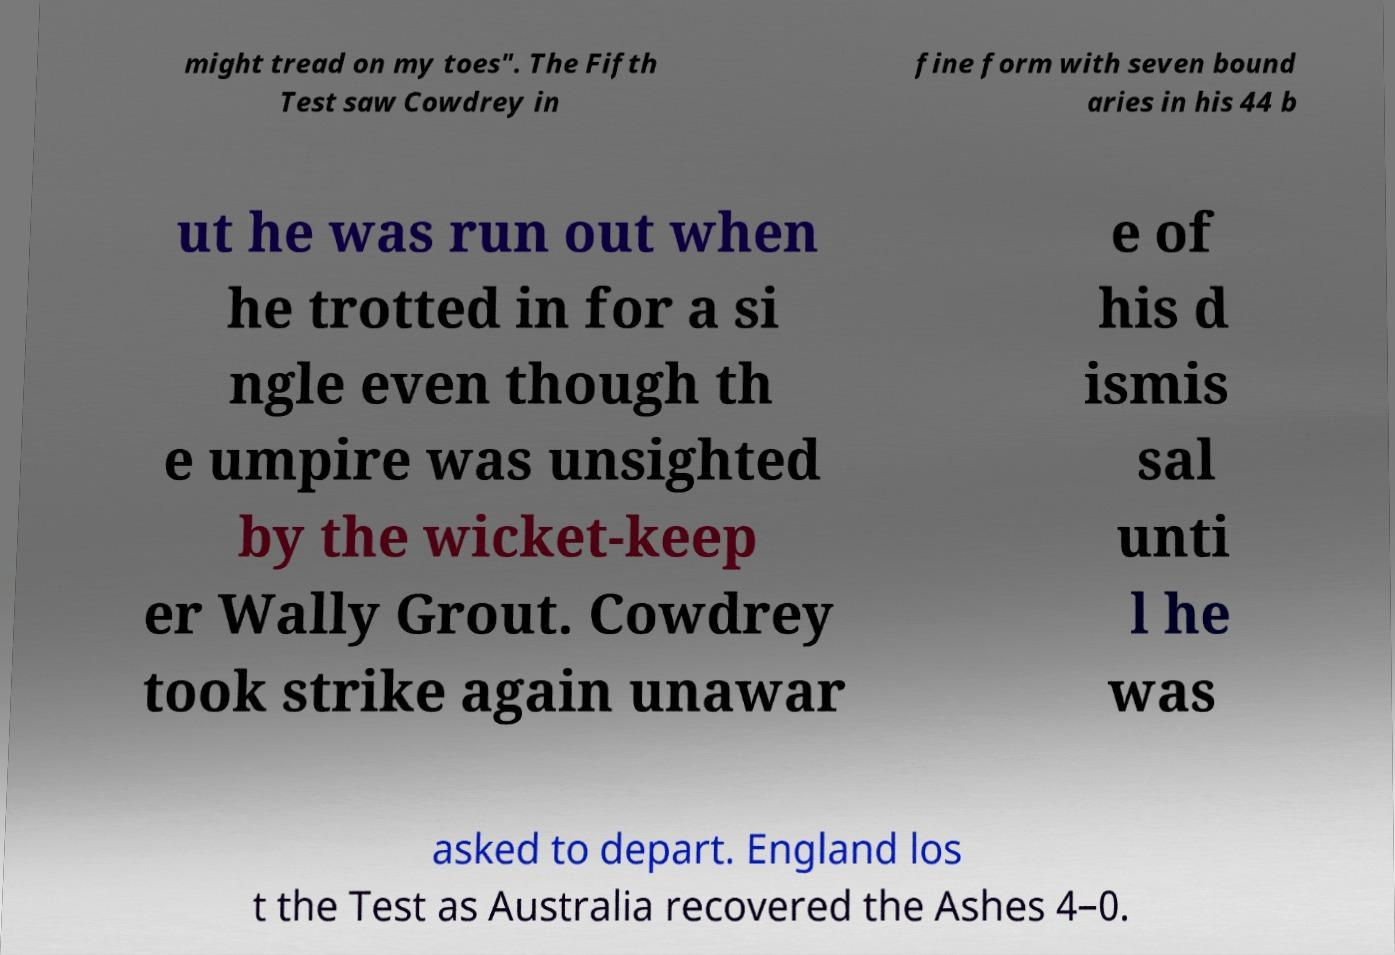There's text embedded in this image that I need extracted. Can you transcribe it verbatim? might tread on my toes". The Fifth Test saw Cowdrey in fine form with seven bound aries in his 44 b ut he was run out when he trotted in for a si ngle even though th e umpire was unsighted by the wicket-keep er Wally Grout. Cowdrey took strike again unawar e of his d ismis sal unti l he was asked to depart. England los t the Test as Australia recovered the Ashes 4–0. 